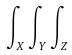Convert formula to latex. <formula><loc_0><loc_0><loc_500><loc_500>\int _ { X } \int _ { Y } \int _ { Z }</formula> 